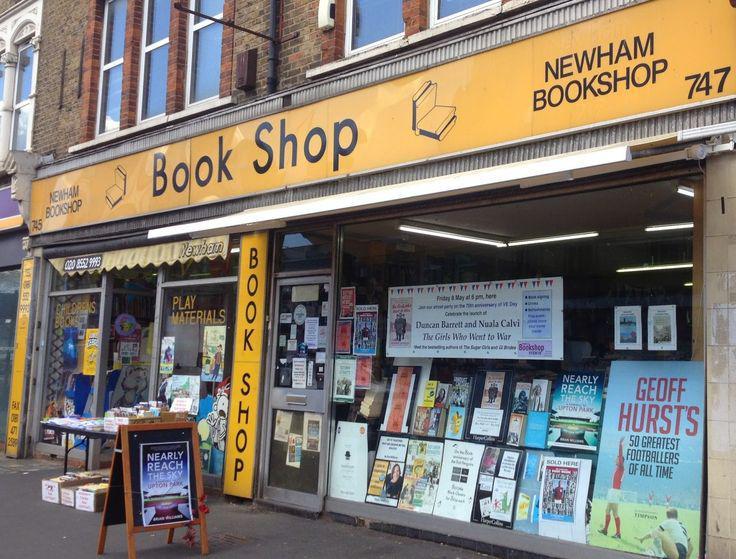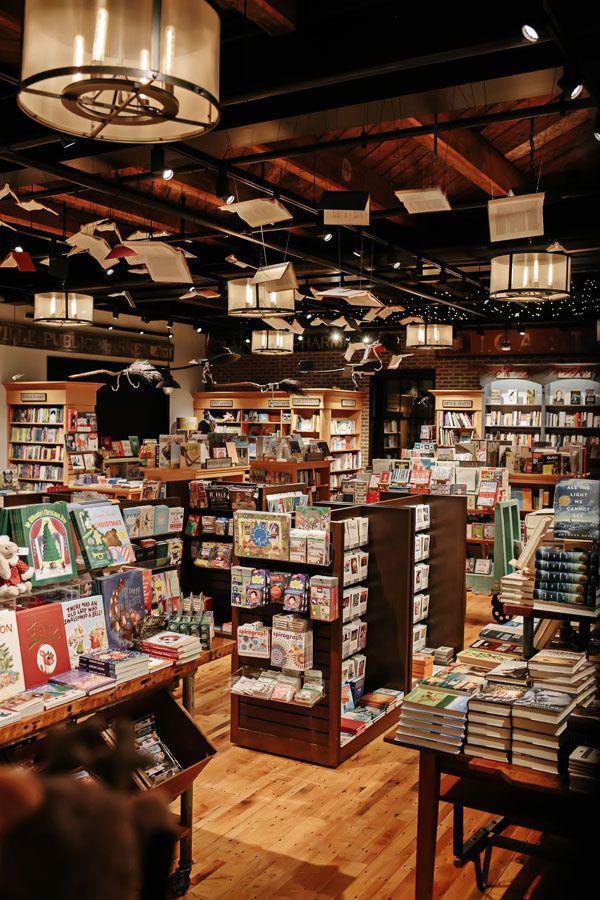The first image is the image on the left, the second image is the image on the right. Assess this claim about the two images: "One of the images displays an outdoor sign, with vertical letters depicting a book store.". Correct or not? Answer yes or no. Yes. The first image is the image on the left, the second image is the image on the right. Evaluate the accuracy of this statement regarding the images: "An image shows the exterior of a bookstore with yellow-background signs above the entrance and running vertically beside a door.". Is it true? Answer yes or no. Yes. 